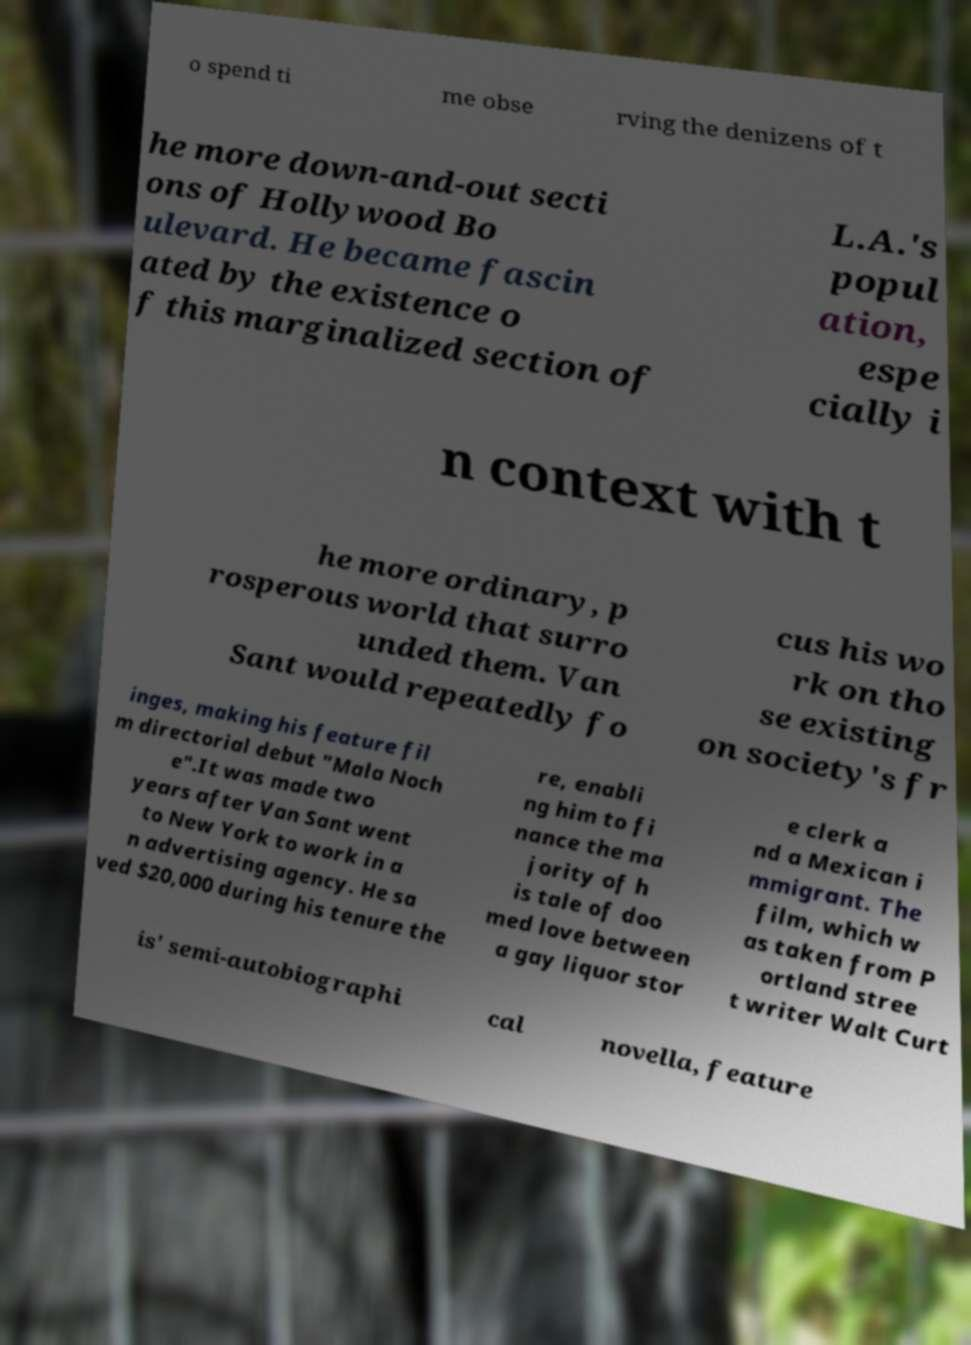Please read and relay the text visible in this image. What does it say? o spend ti me obse rving the denizens of t he more down-and-out secti ons of Hollywood Bo ulevard. He became fascin ated by the existence o f this marginalized section of L.A.'s popul ation, espe cially i n context with t he more ordinary, p rosperous world that surro unded them. Van Sant would repeatedly fo cus his wo rk on tho se existing on society's fr inges, making his feature fil m directorial debut "Mala Noch e".It was made two years after Van Sant went to New York to work in a n advertising agency. He sa ved $20,000 during his tenure the re, enabli ng him to fi nance the ma jority of h is tale of doo med love between a gay liquor stor e clerk a nd a Mexican i mmigrant. The film, which w as taken from P ortland stree t writer Walt Curt is' semi-autobiographi cal novella, feature 